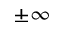Convert formula to latex. <formula><loc_0><loc_0><loc_500><loc_500>\pm \infty</formula> 